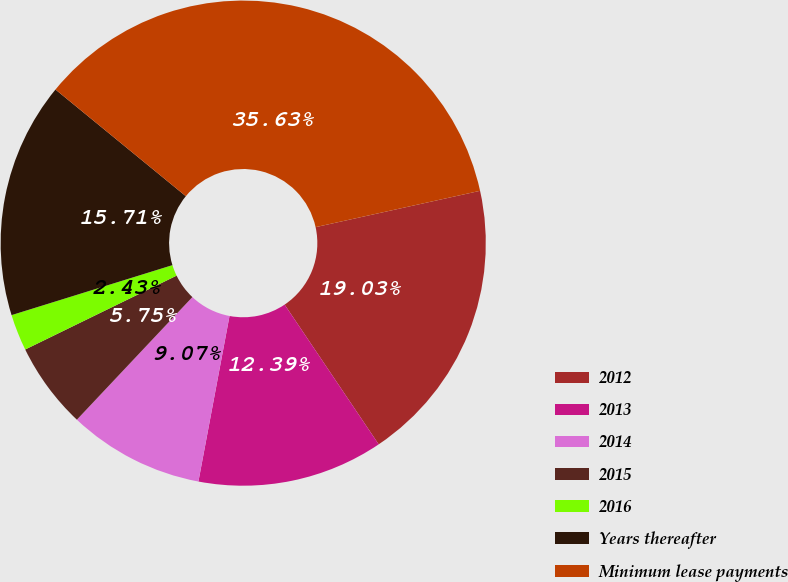Convert chart. <chart><loc_0><loc_0><loc_500><loc_500><pie_chart><fcel>2012<fcel>2013<fcel>2014<fcel>2015<fcel>2016<fcel>Years thereafter<fcel>Minimum lease payments<nl><fcel>19.03%<fcel>12.39%<fcel>9.07%<fcel>5.75%<fcel>2.43%<fcel>15.71%<fcel>35.63%<nl></chart> 